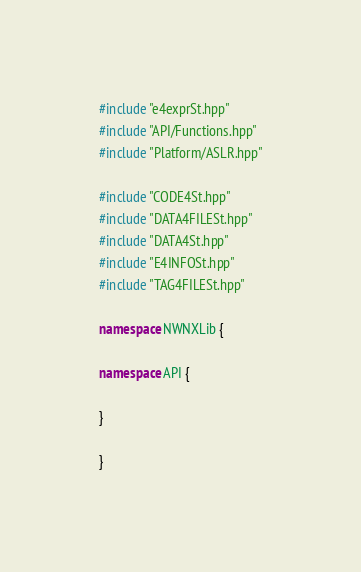<code> <loc_0><loc_0><loc_500><loc_500><_C++_>#include "e4exprSt.hpp"
#include "API/Functions.hpp"
#include "Platform/ASLR.hpp"

#include "CODE4St.hpp"
#include "DATA4FILESt.hpp"
#include "DATA4St.hpp"
#include "E4INFOSt.hpp"
#include "TAG4FILESt.hpp"

namespace NWNXLib {

namespace API {

}

}
</code> 